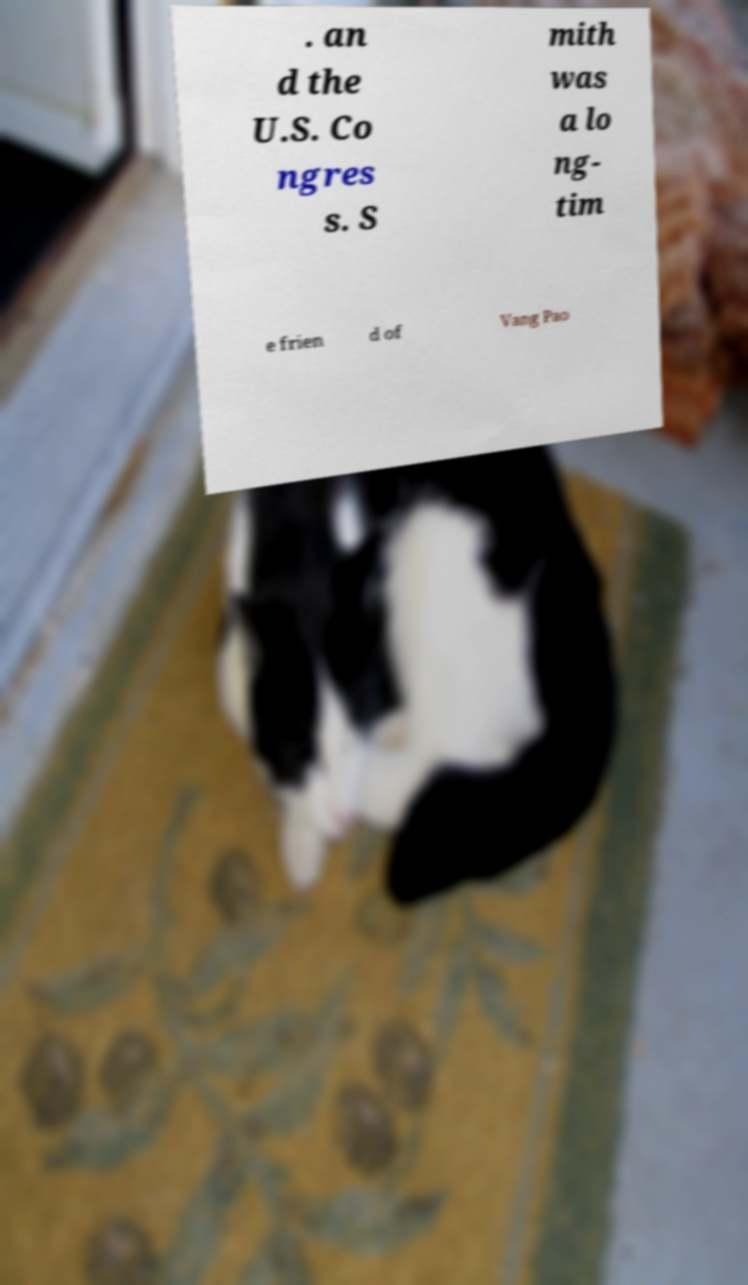Please read and relay the text visible in this image. What does it say? . an d the U.S. Co ngres s. S mith was a lo ng- tim e frien d of Vang Pao 